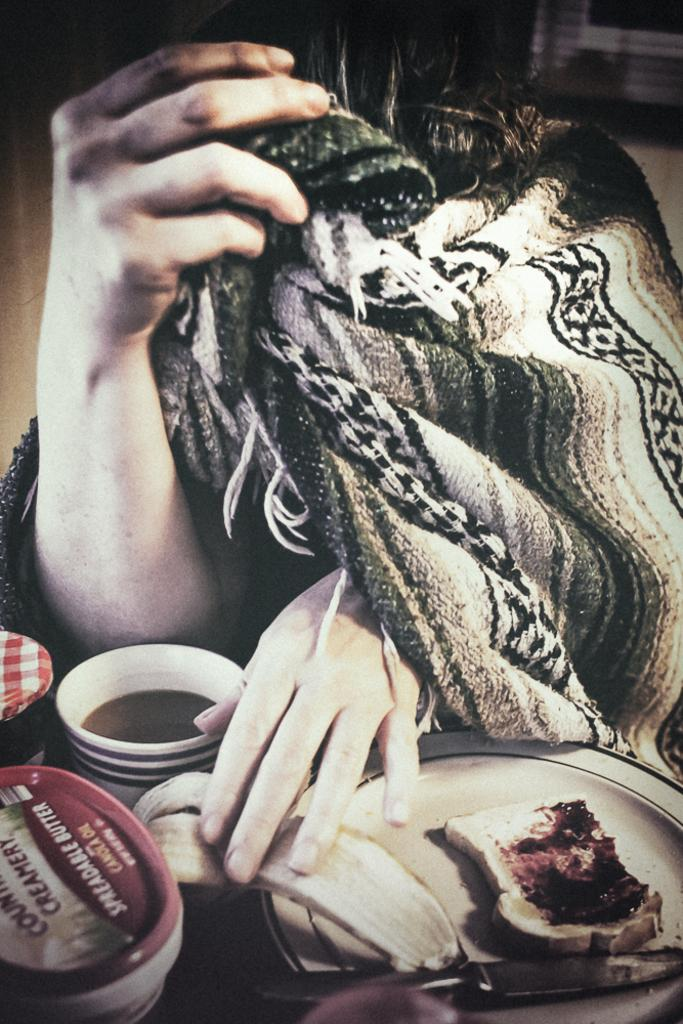Who is present in the image? There is a person in the image. What is the person wearing or holding? The person has a blanket wrapped around them and is holding a banana peel on a plate. What other items are on the plate? There is bread and jam on the plate, along with a knife. Where is the plate located? The plate is on a table. What else can be seen on the table? There is a coffee cup and bottles on the table. How many rings are visible on the person's fingers in the image? There are no rings visible on the person's fingers in the image. Is there a nest in the image? There is no nest present in the image. 